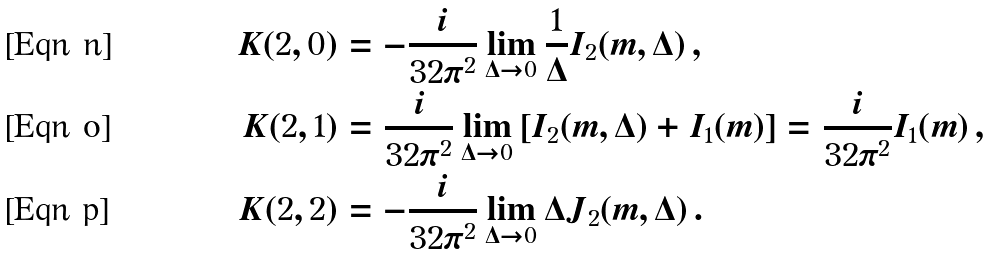Convert formula to latex. <formula><loc_0><loc_0><loc_500><loc_500>K ( 2 , 0 ) & = - \frac { i } { 3 2 \pi ^ { 2 } } \lim _ { \Delta \to 0 } \frac { 1 } { \Delta } I _ { 2 } ( m , \Delta ) \, , \\ K ( 2 , 1 ) & = \frac { i } { 3 2 \pi ^ { 2 } } \lim _ { \Delta \to 0 } \left [ I _ { 2 } ( m , \Delta ) + I _ { 1 } ( m ) \right ] = \frac { i } { 3 2 \pi ^ { 2 } } I _ { 1 } ( m ) \, , \\ K ( 2 , 2 ) & = - \frac { i } { 3 2 \pi ^ { 2 } } \lim _ { \Delta \to 0 } \Delta J _ { 2 } ( m , \Delta ) \, .</formula> 